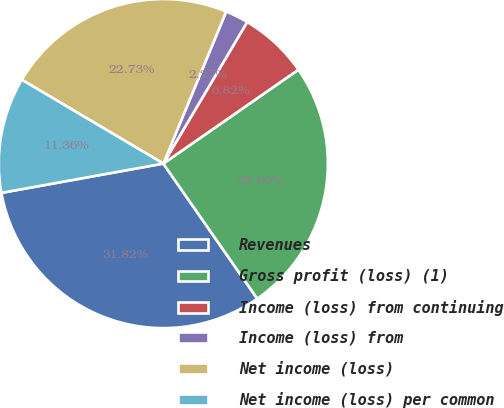Convert chart to OTSL. <chart><loc_0><loc_0><loc_500><loc_500><pie_chart><fcel>Revenues<fcel>Gross profit (loss) (1)<fcel>Income (loss) from continuing<fcel>Income (loss) from<fcel>Net income (loss)<fcel>Net income (loss) per common<nl><fcel>31.82%<fcel>25.0%<fcel>6.82%<fcel>2.27%<fcel>22.73%<fcel>11.36%<nl></chart> 